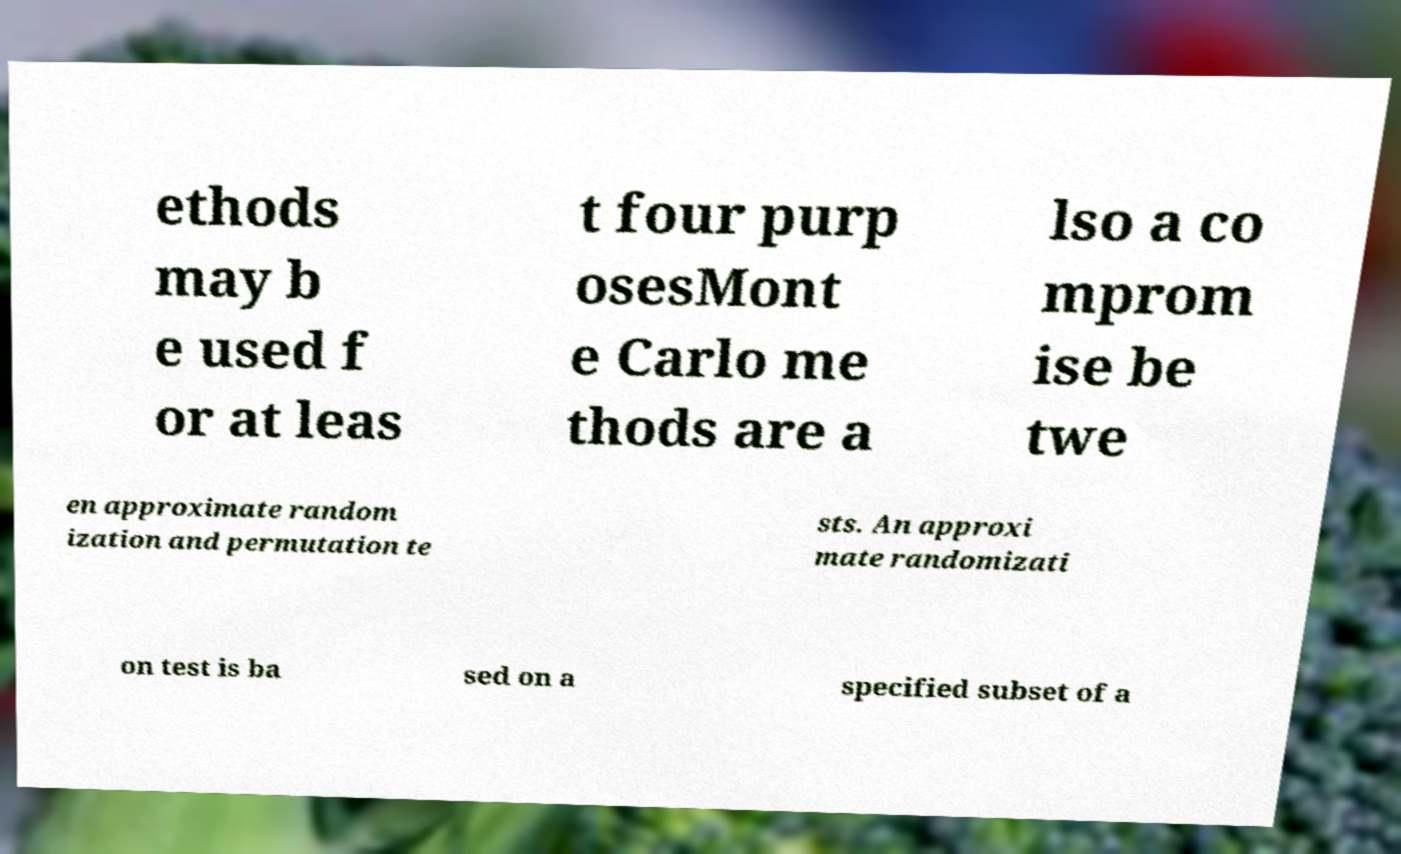Could you extract and type out the text from this image? ethods may b e used f or at leas t four purp osesMont e Carlo me thods are a lso a co mprom ise be twe en approximate random ization and permutation te sts. An approxi mate randomizati on test is ba sed on a specified subset of a 